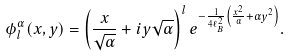<formula> <loc_0><loc_0><loc_500><loc_500>\phi _ { l } ^ { \alpha } ( x , y ) = \left ( \frac { x } { \sqrt { \alpha } } + i y \sqrt { \alpha } \right ) ^ { l } e ^ { - \frac { 1 } { 4 \ell _ { B } ^ { 2 } } \left ( \frac { x ^ { 2 } } { \alpha } + \alpha y ^ { 2 } \right ) } .</formula> 